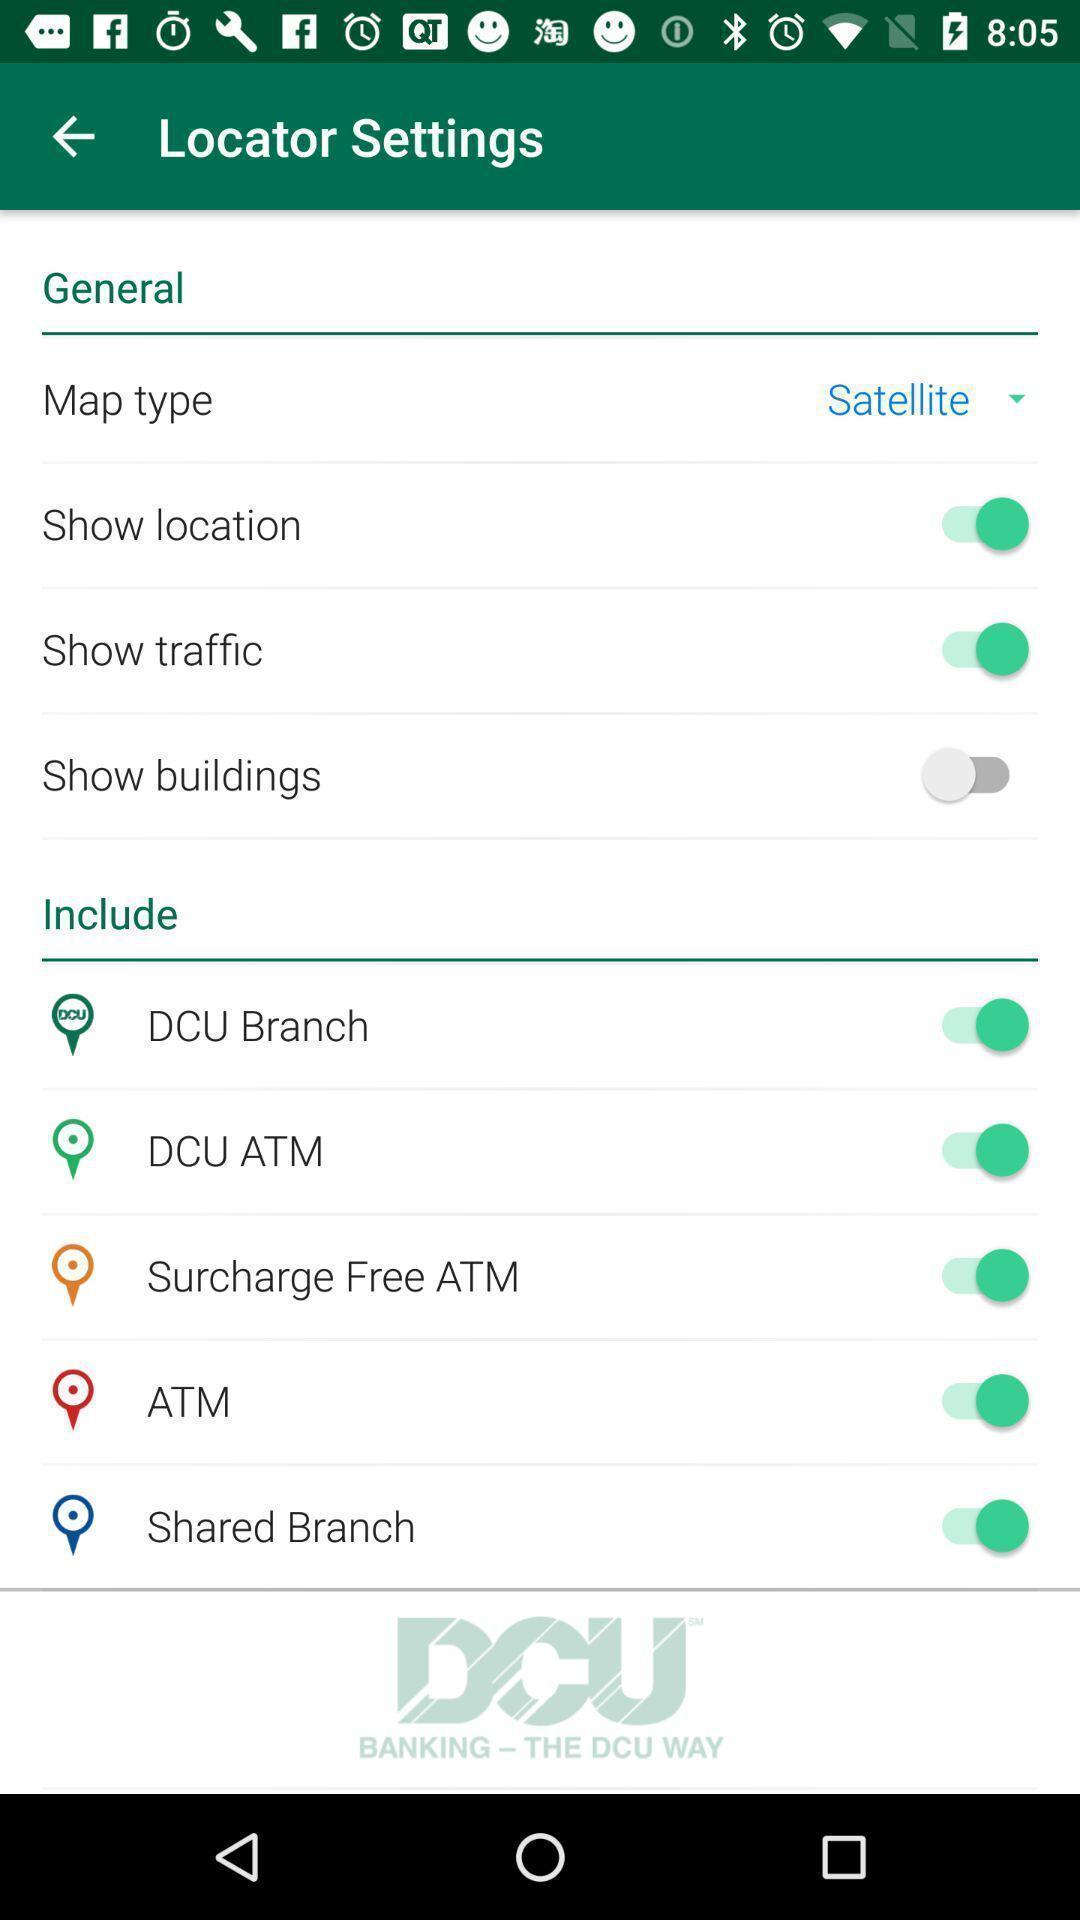Give me a summary of this screen capture. Settings page of financial app. 